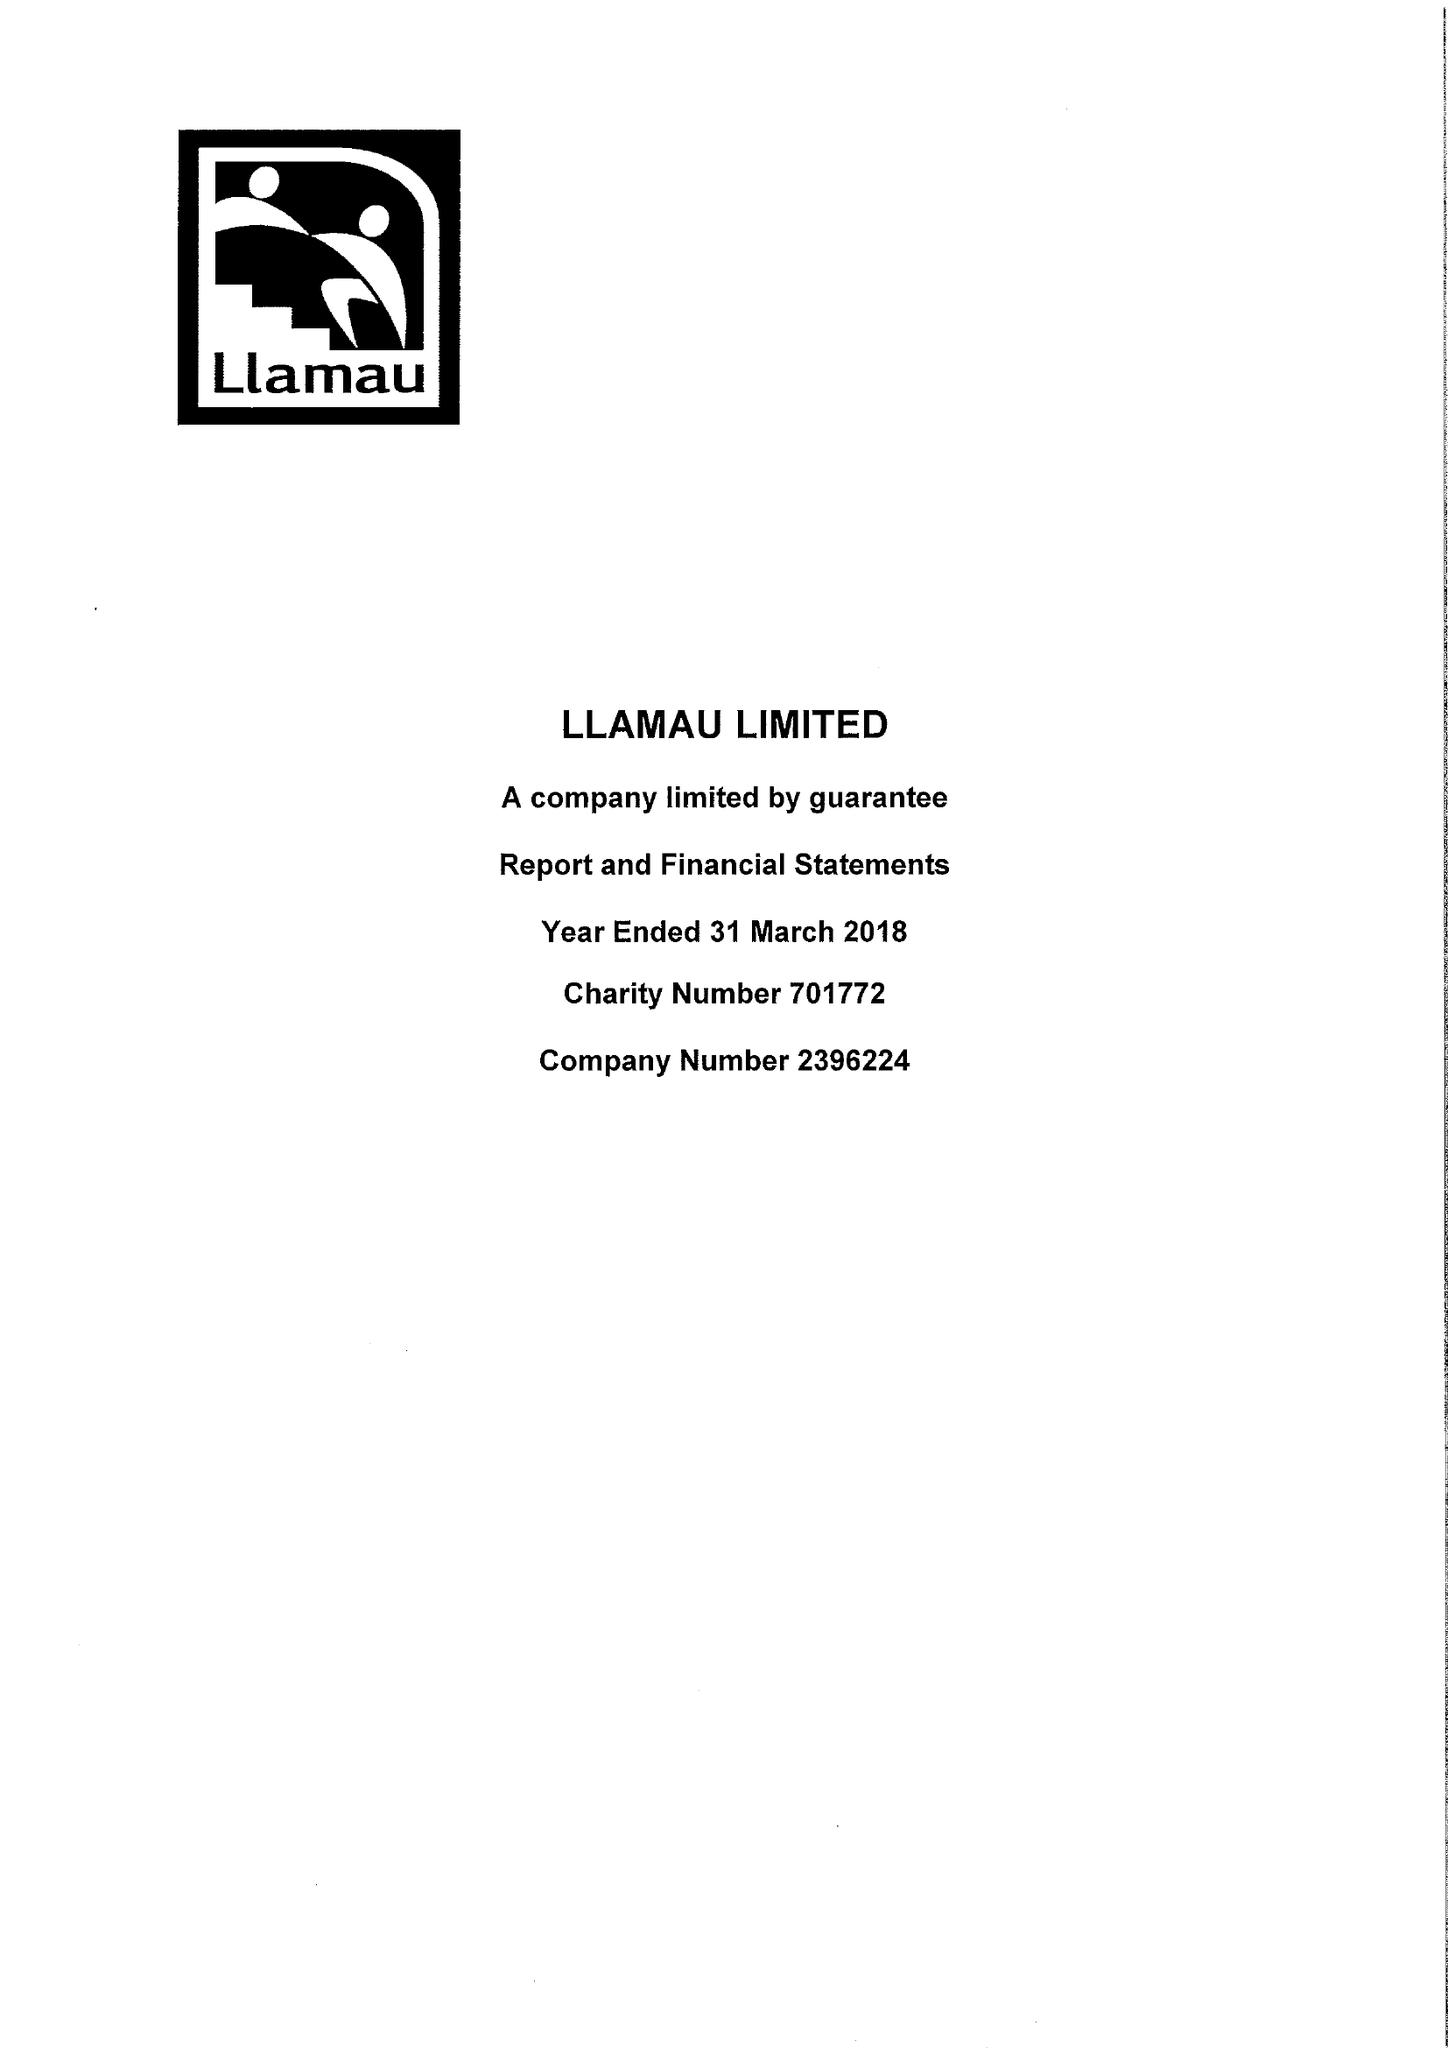What is the value for the charity_name?
Answer the question using a single word or phrase. Llamau Ltd. 